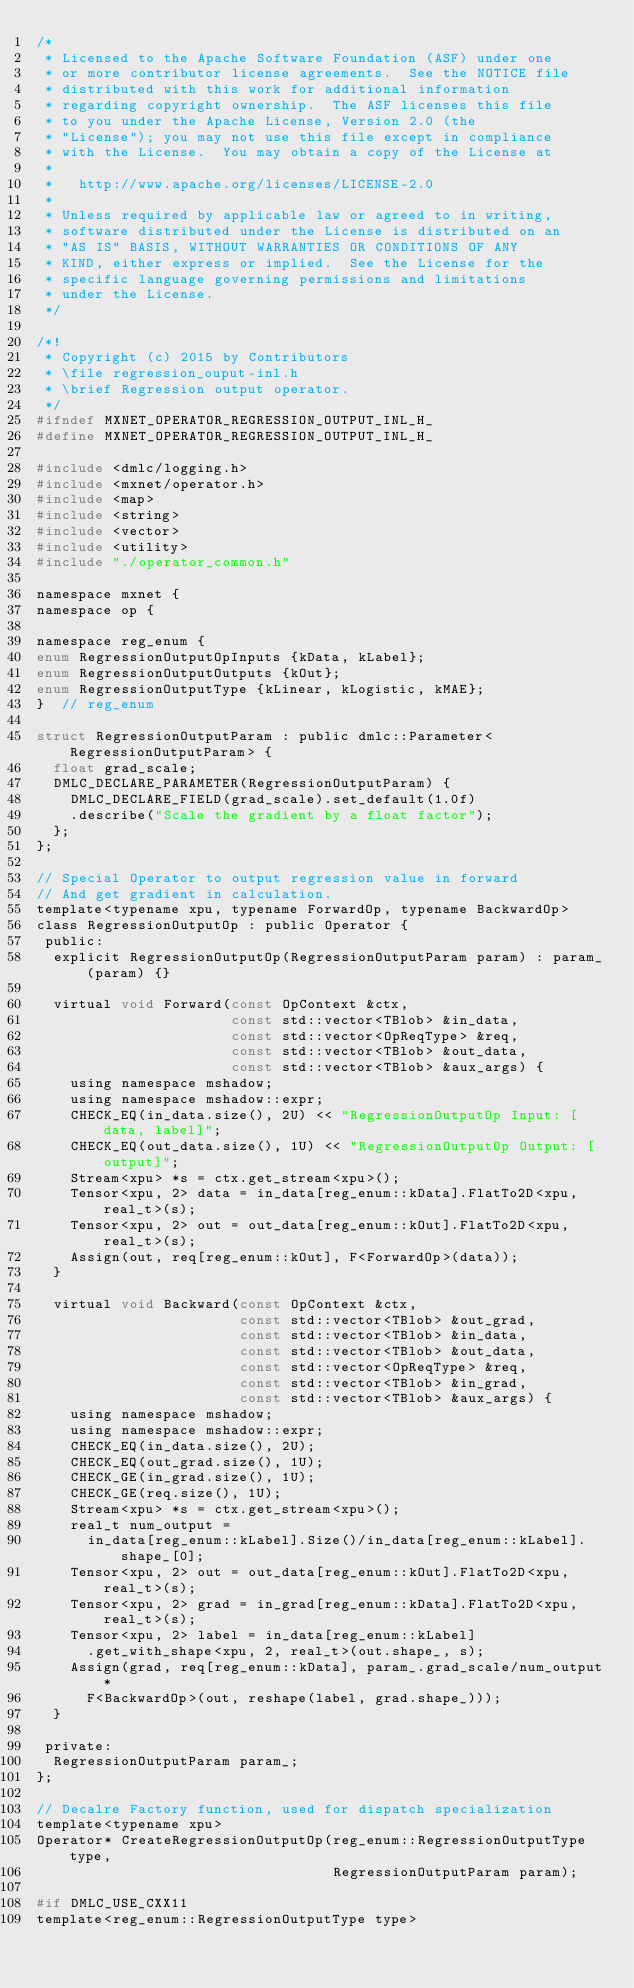Convert code to text. <code><loc_0><loc_0><loc_500><loc_500><_C_>/*
 * Licensed to the Apache Software Foundation (ASF) under one
 * or more contributor license agreements.  See the NOTICE file
 * distributed with this work for additional information
 * regarding copyright ownership.  The ASF licenses this file
 * to you under the Apache License, Version 2.0 (the
 * "License"); you may not use this file except in compliance
 * with the License.  You may obtain a copy of the License at
 *
 *   http://www.apache.org/licenses/LICENSE-2.0
 *
 * Unless required by applicable law or agreed to in writing,
 * software distributed under the License is distributed on an
 * "AS IS" BASIS, WITHOUT WARRANTIES OR CONDITIONS OF ANY
 * KIND, either express or implied.  See the License for the
 * specific language governing permissions and limitations
 * under the License.
 */

/*!
 * Copyright (c) 2015 by Contributors
 * \file regression_ouput-inl.h
 * \brief Regression output operator.
 */
#ifndef MXNET_OPERATOR_REGRESSION_OUTPUT_INL_H_
#define MXNET_OPERATOR_REGRESSION_OUTPUT_INL_H_

#include <dmlc/logging.h>
#include <mxnet/operator.h>
#include <map>
#include <string>
#include <vector>
#include <utility>
#include "./operator_common.h"

namespace mxnet {
namespace op {

namespace reg_enum {
enum RegressionOutputOpInputs {kData, kLabel};
enum RegressionOutputOutputs {kOut};
enum RegressionOutputType {kLinear, kLogistic, kMAE};
}  // reg_enum

struct RegressionOutputParam : public dmlc::Parameter<RegressionOutputParam> {
  float grad_scale;
  DMLC_DECLARE_PARAMETER(RegressionOutputParam) {
    DMLC_DECLARE_FIELD(grad_scale).set_default(1.0f)
    .describe("Scale the gradient by a float factor");
  };
};

// Special Operator to output regression value in forward
// And get gradient in calculation.
template<typename xpu, typename ForwardOp, typename BackwardOp>
class RegressionOutputOp : public Operator {
 public:
  explicit RegressionOutputOp(RegressionOutputParam param) : param_(param) {}

  virtual void Forward(const OpContext &ctx,
                       const std::vector<TBlob> &in_data,
                       const std::vector<OpReqType> &req,
                       const std::vector<TBlob> &out_data,
                       const std::vector<TBlob> &aux_args) {
    using namespace mshadow;
    using namespace mshadow::expr;
    CHECK_EQ(in_data.size(), 2U) << "RegressionOutputOp Input: [data, label]";
    CHECK_EQ(out_data.size(), 1U) << "RegressionOutputOp Output: [output]";
    Stream<xpu> *s = ctx.get_stream<xpu>();
    Tensor<xpu, 2> data = in_data[reg_enum::kData].FlatTo2D<xpu, real_t>(s);
    Tensor<xpu, 2> out = out_data[reg_enum::kOut].FlatTo2D<xpu, real_t>(s);
    Assign(out, req[reg_enum::kOut], F<ForwardOp>(data));
  }

  virtual void Backward(const OpContext &ctx,
                        const std::vector<TBlob> &out_grad,
                        const std::vector<TBlob> &in_data,
                        const std::vector<TBlob> &out_data,
                        const std::vector<OpReqType> &req,
                        const std::vector<TBlob> &in_grad,
                        const std::vector<TBlob> &aux_args) {
    using namespace mshadow;
    using namespace mshadow::expr;
    CHECK_EQ(in_data.size(), 2U);
    CHECK_EQ(out_grad.size(), 1U);
    CHECK_GE(in_grad.size(), 1U);
    CHECK_GE(req.size(), 1U);
    Stream<xpu> *s = ctx.get_stream<xpu>();
    real_t num_output =
      in_data[reg_enum::kLabel].Size()/in_data[reg_enum::kLabel].shape_[0];
    Tensor<xpu, 2> out = out_data[reg_enum::kOut].FlatTo2D<xpu, real_t>(s);
    Tensor<xpu, 2> grad = in_grad[reg_enum::kData].FlatTo2D<xpu, real_t>(s);
    Tensor<xpu, 2> label = in_data[reg_enum::kLabel]
      .get_with_shape<xpu, 2, real_t>(out.shape_, s);
    Assign(grad, req[reg_enum::kData], param_.grad_scale/num_output*
      F<BackwardOp>(out, reshape(label, grad.shape_)));
  }

 private:
  RegressionOutputParam param_;
};

// Decalre Factory function, used for dispatch specialization
template<typename xpu>
Operator* CreateRegressionOutputOp(reg_enum::RegressionOutputType type,
                                   RegressionOutputParam param);

#if DMLC_USE_CXX11
template<reg_enum::RegressionOutputType type></code> 